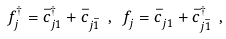<formula> <loc_0><loc_0><loc_500><loc_500>f _ { j } ^ { \dagger } = \bar { c } ^ { \dagger } _ { j 1 } + \bar { c } ^ { \, } _ { j \bar { 1 } } \ , \ f _ { j } ^ { \, } = \bar { c } ^ { \, } _ { j 1 } + \bar { c } ^ { \dagger } _ { j \bar { 1 } } \ ,</formula> 